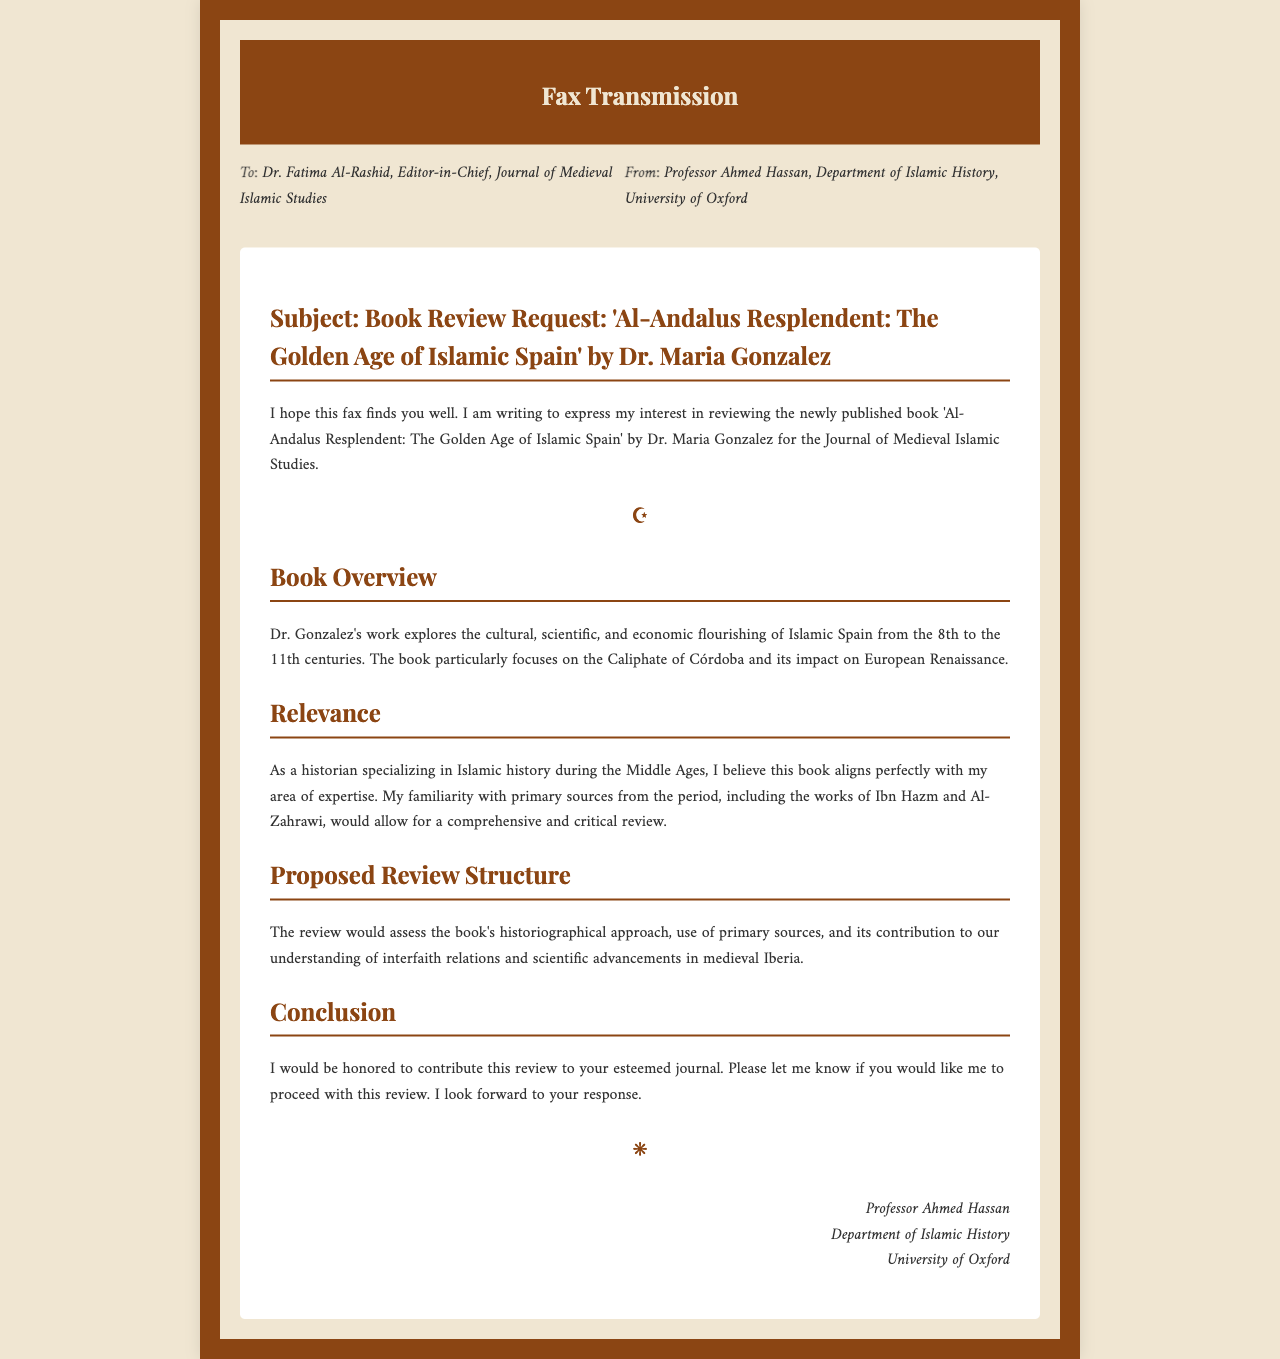What is the title of the book being reviewed? The title of the book is mentioned in the subject line of the fax.
Answer: Al-Andalus Resplendent: The Golden Age of Islamic Spain Who is the author of the book? The author's name is provided in the subject line of the fax.
Answer: Dr. Maria Gonzalez Which publication is the review intended for? The intended publication is specified in the address section of the fax.
Answer: Journal of Medieval Islamic Studies What time period does Dr. Gonzalez's book focus on? The time period is described in the overview section of the fax.
Answer: 8th to the 11th centuries What position does the sender of the fax hold? The sender's position is mentioned in the signature section of the fax.
Answer: Professor What is the main theme of the book? The main theme is summarized in the book overview section of the fax.
Answer: Cultural, scientific, and economic flourishing What specific focus does the book have within its theme? The specific focus is detailed in the book overview section.
Answer: Caliphate of Córdoba What type of sources does Professor Ahmed Hassan mention he is familiar with? The type of sources is stated in the relevance section of the fax.
Answer: Primary sources What is the proposed content of the review? The content of the review is outlined in the proposed review structure section.
Answer: Historiographical approach and primary sources assessment 